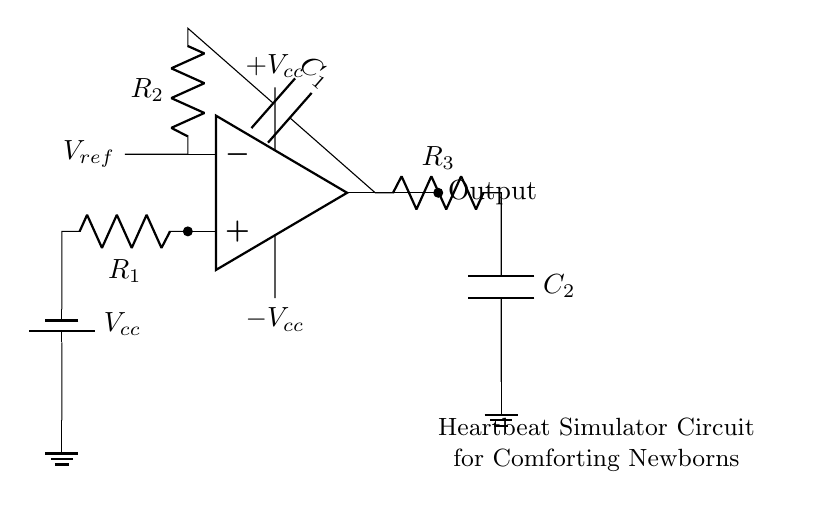What is the main component used to generate the heartbeat simulation? The operational amplifier is the primary active component used to create the oscillation needed for the heartbeat simulation. It amplifies the input signals and shapes the output waveform.
Answer: Operational amplifier What type of circuit is this? This circuit is a low-frequency oscillator specifically designed to simulate a heartbeat, which produces repetitive waveform outputs at low frequencies.
Answer: Low-frequency oscillator How many resistors are in the circuit? There are three resistors present in the circuit, which are labeled as R1, R2, and R3. Each of these components contributes to controlling the frequency and shape of the output signal.
Answer: Three What is the purpose of capacitor C1? Capacitor C1 is used in conjunction with resistor R2 to set the timing parameters of the oscillator, contributing to the frequency of oscillation and smoothing the output waveform.
Answer: Timing What is the role of the output connection? The output connection allows the circuit to deliver the generated heartbeat simulation signal to external devices, such as a speaker or other components that can utilize the waveform for calming newborns.
Answer: Deliver the signal What does Vcc represent in this circuit? Vcc represents the positive supply voltage for the operational amplifier, providing the necessary power for the circuit to function and generate the oscillation.
Answer: Positive supply voltage Why are the resistors and capacitors selected for this circuit? The specific values of the resistors and capacitors are chosen to achieve the desired frequency range that mimics a human heartbeat, typically around 60 to 80 beats per minute, ensuring effective calming for newborns.
Answer: Desired frequency range 